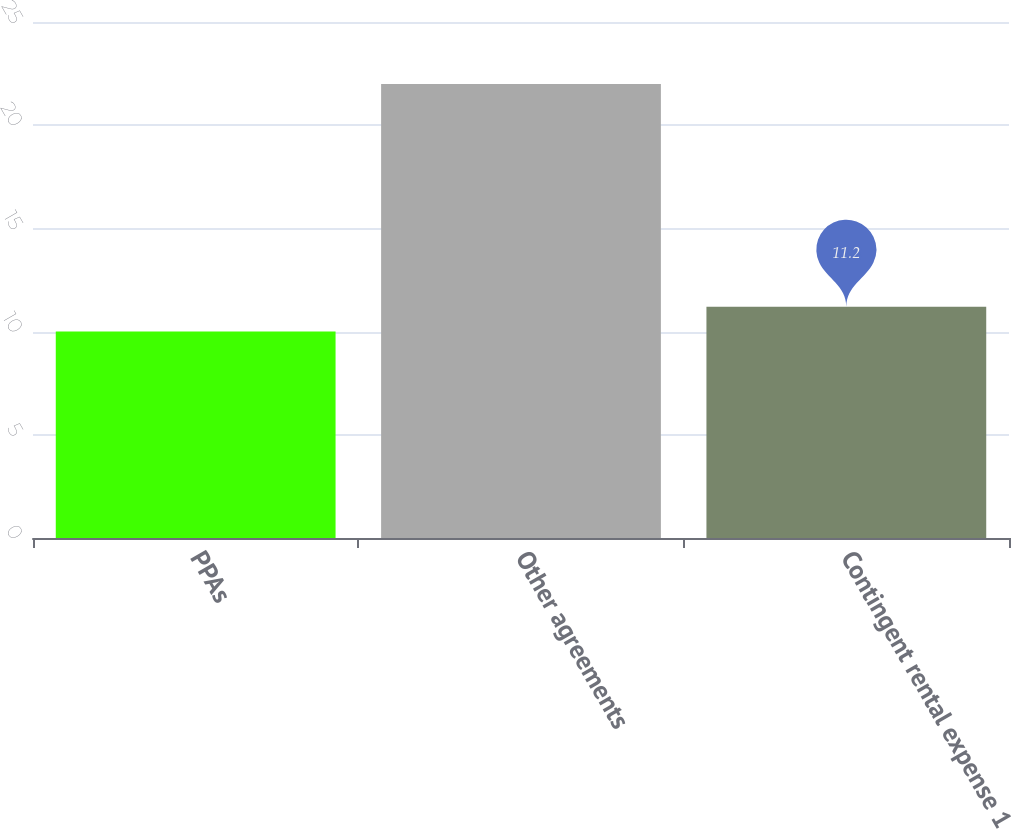<chart> <loc_0><loc_0><loc_500><loc_500><bar_chart><fcel>PPAs<fcel>Other agreements<fcel>Contingent rental expense 1<nl><fcel>10<fcel>22<fcel>11.2<nl></chart> 